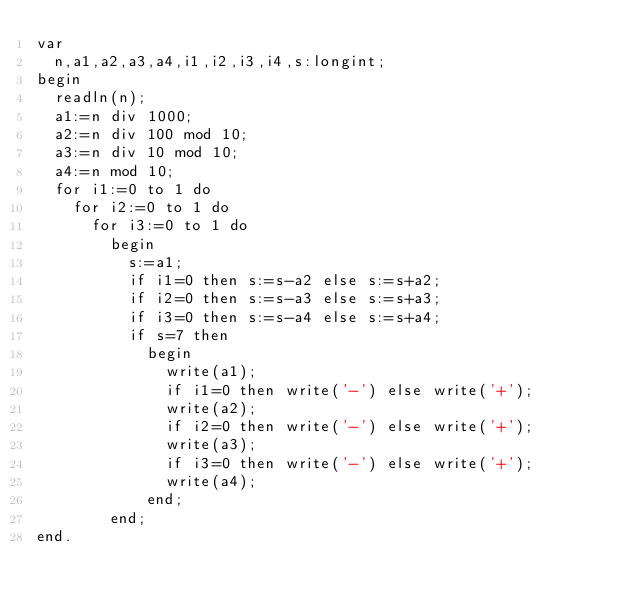Convert code to text. <code><loc_0><loc_0><loc_500><loc_500><_Pascal_>var
  n,a1,a2,a3,a4,i1,i2,i3,i4,s:longint;
begin
  readln(n);
  a1:=n div 1000;
  a2:=n div 100 mod 10;
  a3:=n div 10 mod 10;
  a4:=n mod 10;
  for i1:=0 to 1 do
    for i2:=0 to 1 do
      for i3:=0 to 1 do
        begin
          s:=a1;
          if i1=0 then s:=s-a2 else s:=s+a2;
          if i2=0 then s:=s-a3 else s:=s+a3;
          if i3=0 then s:=s-a4 else s:=s+a4;
          if s=7 then
            begin
              write(a1);
              if i1=0 then write('-') else write('+');
              write(a2);
              if i2=0 then write('-') else write('+');
              write(a3);
              if i3=0 then write('-') else write('+');
              write(a4);
            end;
        end;
end.</code> 